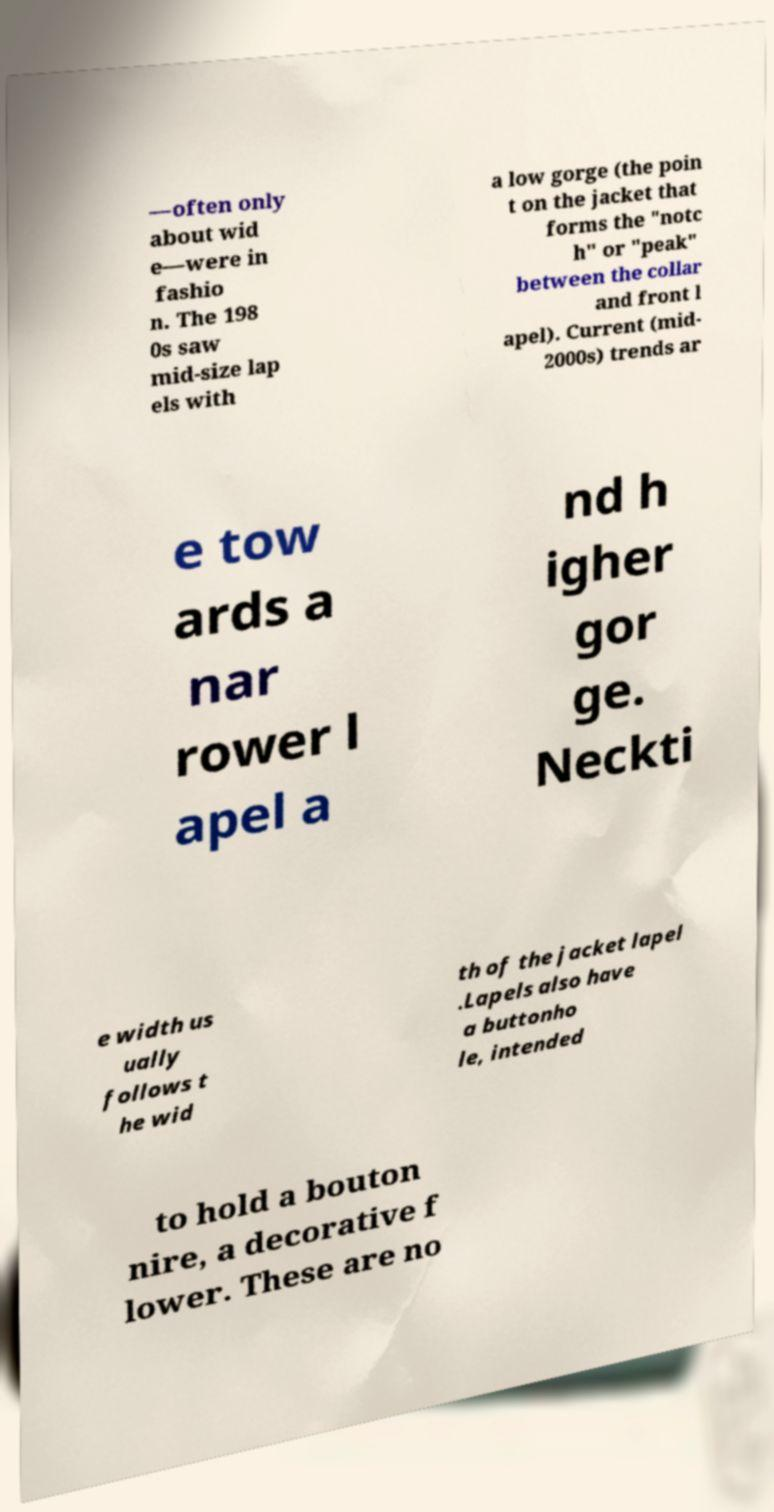What messages or text are displayed in this image? I need them in a readable, typed format. —often only about wid e—were in fashio n. The 198 0s saw mid-size lap els with a low gorge (the poin t on the jacket that forms the "notc h" or "peak" between the collar and front l apel). Current (mid- 2000s) trends ar e tow ards a nar rower l apel a nd h igher gor ge. Neckti e width us ually follows t he wid th of the jacket lapel .Lapels also have a buttonho le, intended to hold a bouton nire, a decorative f lower. These are no 